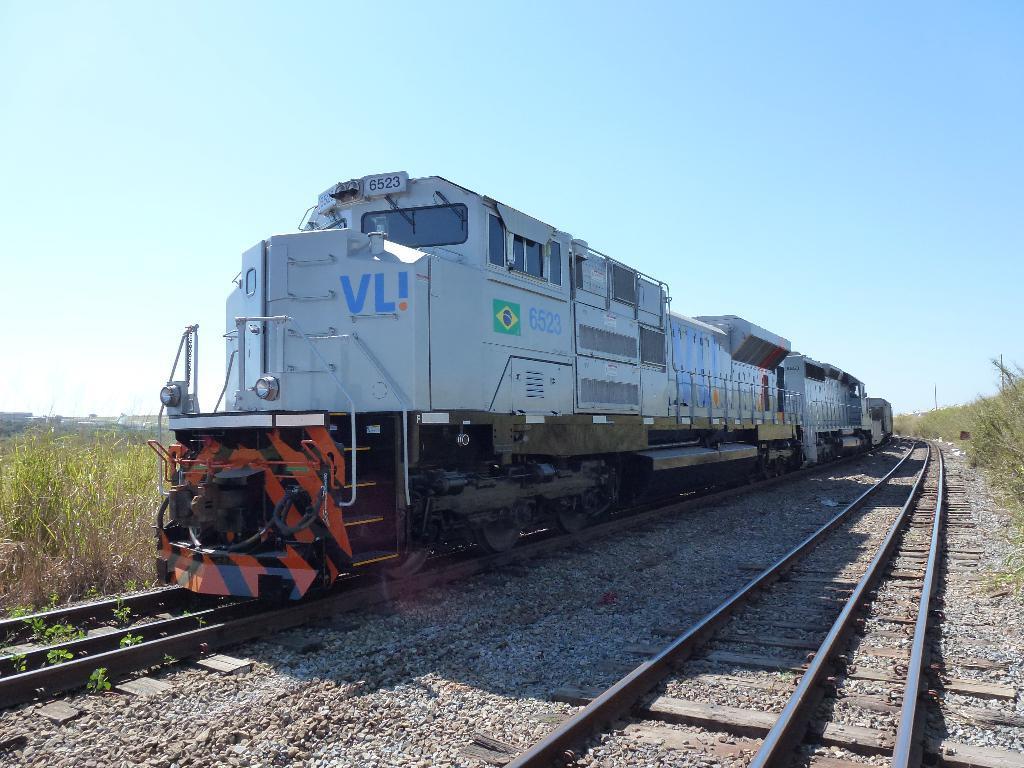Describe this image in one or two sentences. In this image I can see the ground, few railway tracks on the ground, few plants which are green and brown in color and a train on the railway track. In the background I can see the sky. 